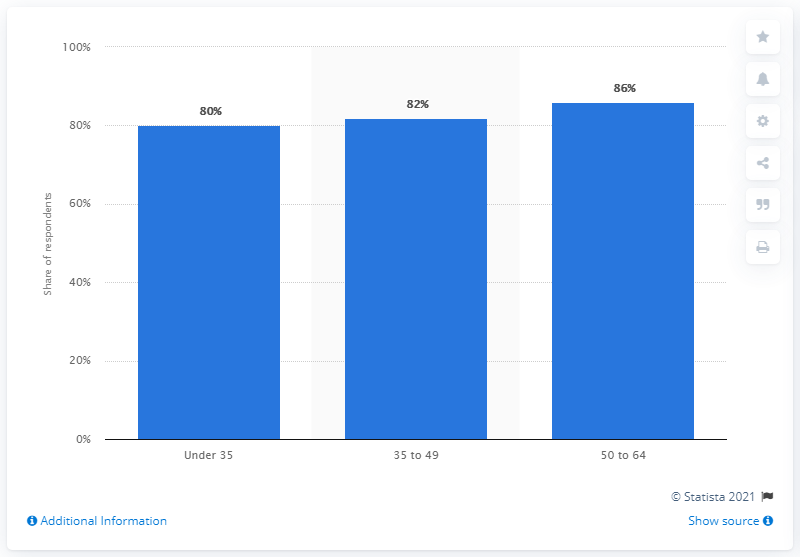Give some essential details in this illustration. The highest level of penetration was observed among individuals aged 50 to 64, 